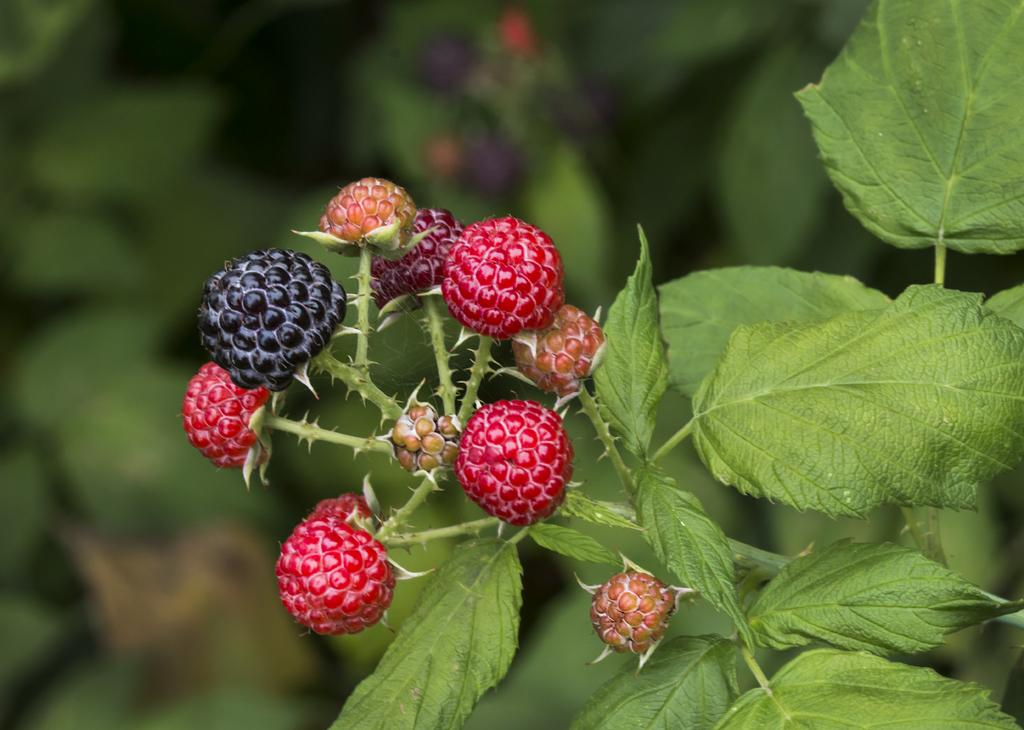What type of food can be seen in the image? There are fruits in the image. What else is present in the image besides the fruits? There are leaves in the image. What type of fan can be seen in the image? There is no fan present in the image. 